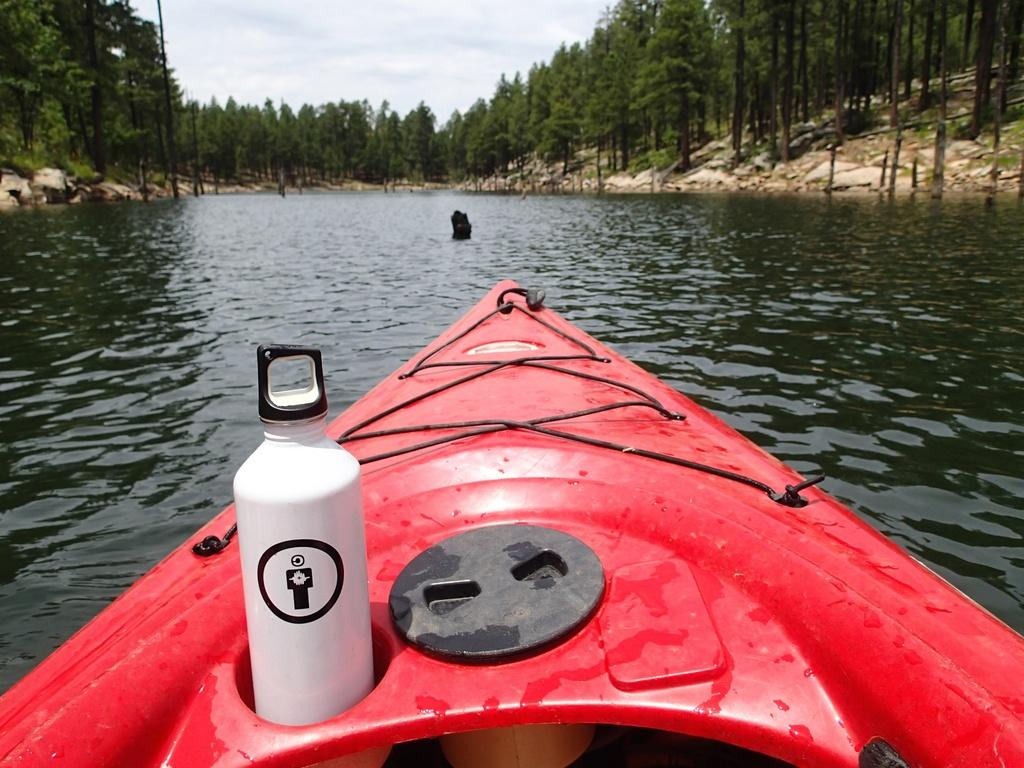What is the main subject in the foreground of the image? There is a boat in the foreground of the image. What else can be seen in the foreground of the image? There is a bottle in the water in the foreground of the image. What is visible in the background of the image? There are stones, trees, and the sky visible in the background of the image. What might be the location of the image? The image may have been taken near a lake, based on the presence of water and the boat. What type of thrill can be seen on the locket in the image? There is no locket present in the image, and therefore no such activity or object can be observed. 